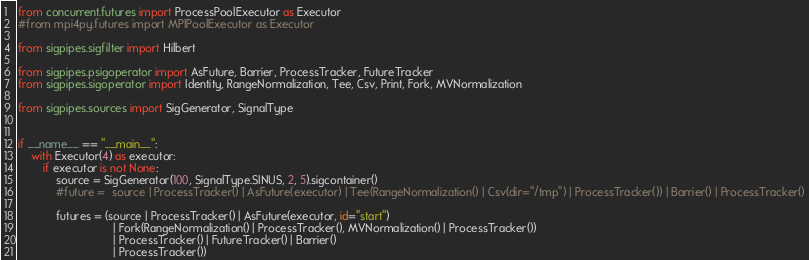<code> <loc_0><loc_0><loc_500><loc_500><_Python_>from concurrent.futures import ProcessPoolExecutor as Executor
#from mpi4py.futures import MPIPoolExecutor as Executor

from sigpipes.sigfilter import Hilbert

from sigpipes.psigoperator import AsFuture, Barrier, ProcessTracker, FutureTracker
from sigpipes.sigoperator import Identity, RangeNormalization, Tee, Csv, Print, Fork, MVNormalization

from sigpipes.sources import SigGenerator, SignalType


if __name__ == "__main__":
    with Executor(4) as executor:
        if executor is not None:
            source = SigGenerator(100, SignalType.SINUS, 2, 5).sigcontainer()
            #future =  source | ProcessTracker() | AsFuture(executor) | Tee(RangeNormalization() | Csv(dir="/tmp") | ProcessTracker()) | Barrier() | ProcessTracker()

            futures = (source | ProcessTracker() | AsFuture(executor, id="start")
                              | Fork(RangeNormalization() | ProcessTracker(), MVNormalization() | ProcessTracker())
                              | ProcessTracker() | FutureTracker() | Barrier()
                              | ProcessTracker())
</code> 